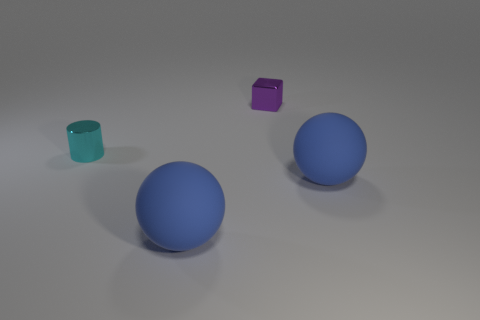There is a tiny object that is on the right side of the cyan thing; is it the same shape as the cyan object?
Ensure brevity in your answer.  No. There is a object that is to the left of the big matte thing left of the purple metallic block that is on the right side of the cyan cylinder; what is its size?
Ensure brevity in your answer.  Small. How many things are either big rubber cylinders or cyan objects?
Keep it short and to the point. 1. Do the small purple object and the big object that is right of the small purple cube have the same shape?
Ensure brevity in your answer.  No. There is a purple metallic block; are there any cyan metallic cylinders on the right side of it?
Make the answer very short. No. What number of balls are large rubber objects or purple objects?
Make the answer very short. 2. Do the cyan metallic thing and the purple object have the same shape?
Ensure brevity in your answer.  No. How big is the sphere right of the block?
Ensure brevity in your answer.  Large. Is there a large thing of the same color as the cylinder?
Ensure brevity in your answer.  No. There is a thing behind the cyan cylinder; is its size the same as the metallic cylinder?
Offer a very short reply. Yes. 